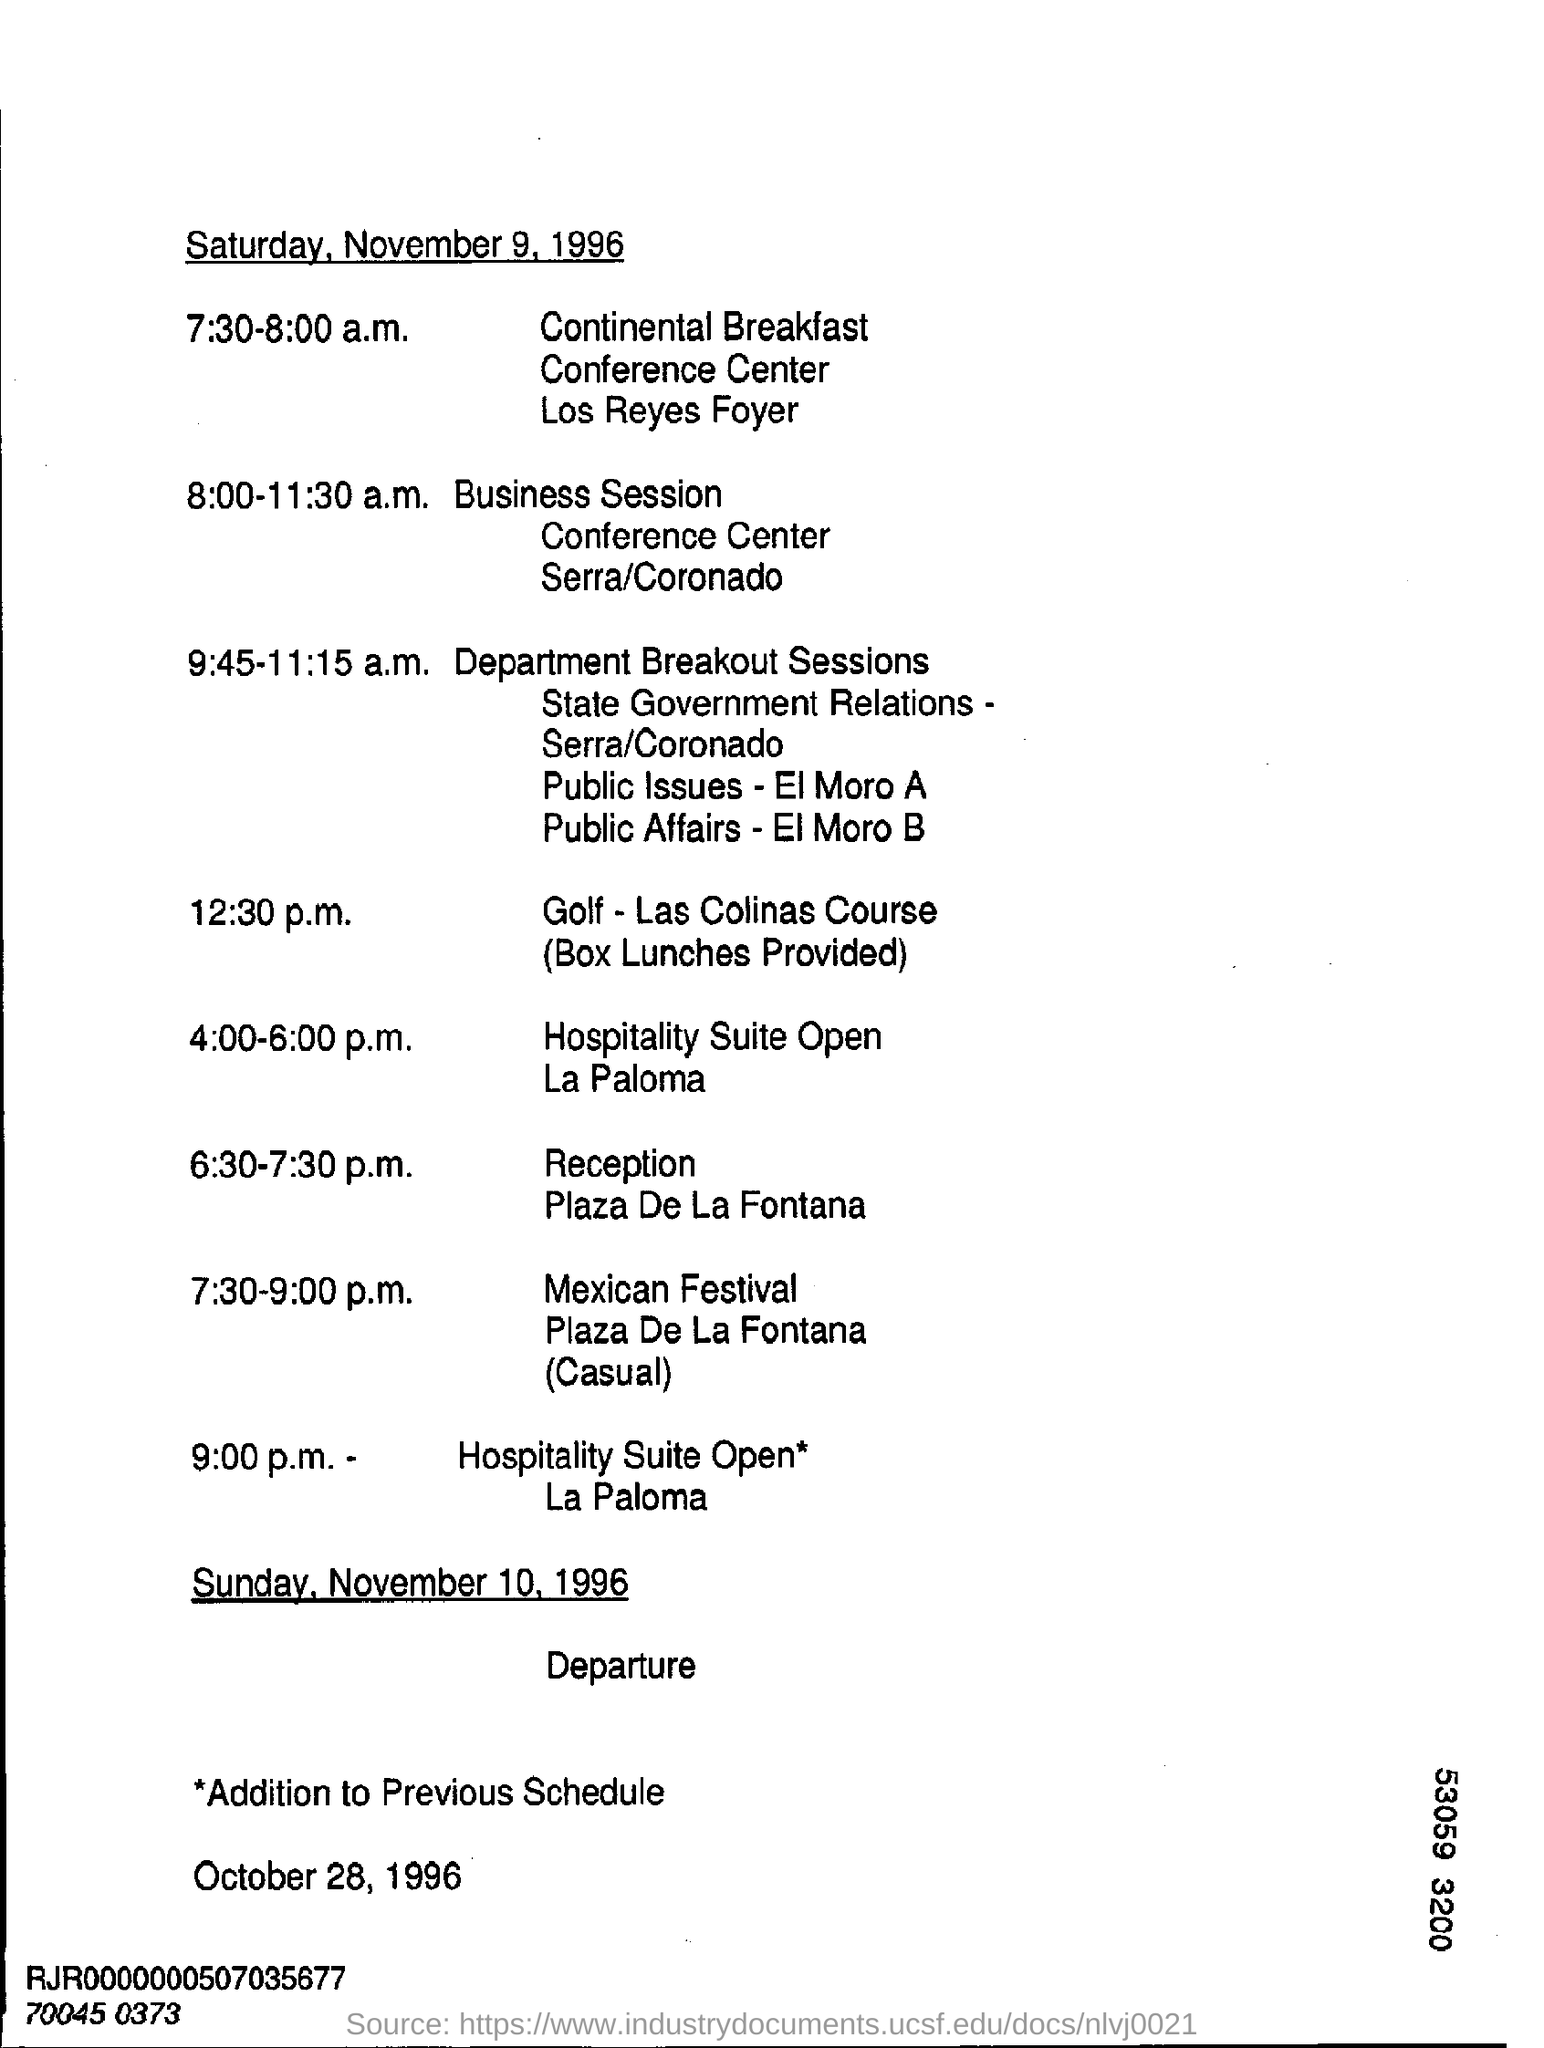What is the date mentioned in the top of the document ?
Make the answer very short. Saturday, November 9, 1996. What is the timing  of Golf - Las Colinas Course ?
Ensure brevity in your answer.  12:30 p.m. What is the date mentioned in the bottom of the document ?
Keep it short and to the point. October 28, 1996. What is the Timing of Reception  ?
Keep it short and to the point. 6.30-7.30 p.m. 